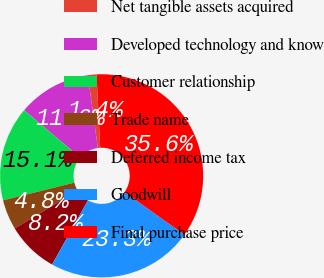Convert chart. <chart><loc_0><loc_0><loc_500><loc_500><pie_chart><fcel>Net tangible assets acquired<fcel>Developed technology and know<fcel>Customer relationship<fcel>Trade name<fcel>Deferred income tax<fcel>Goodwill<fcel>Final purchase price<nl><fcel>1.36%<fcel>11.65%<fcel>15.07%<fcel>4.79%<fcel>8.22%<fcel>23.27%<fcel>35.64%<nl></chart> 